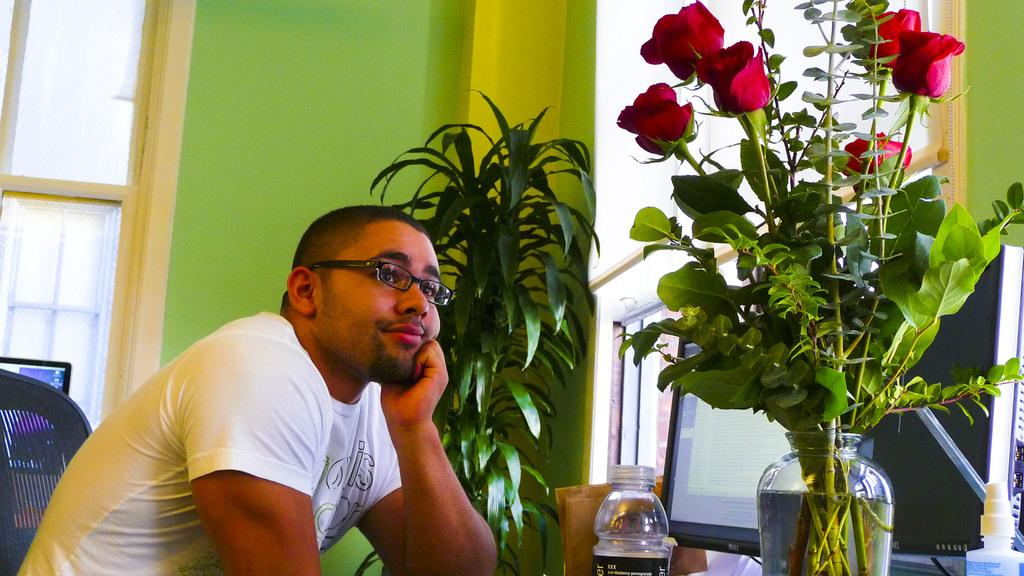Who is present in the image? There is a person in the image. What can be observed about the person's appearance? The person is wearing spectacles. What is the person doing in the image? The person is sitting on a chair. What type of vegetation is present in the image? There are potted plants in the image. Where are the potted plants located in relation to the window? The potted plants are near a window. How many legs does the receipt have in the image? There is no receipt present in the image, so it is not possible to determine how many legs it might have. 